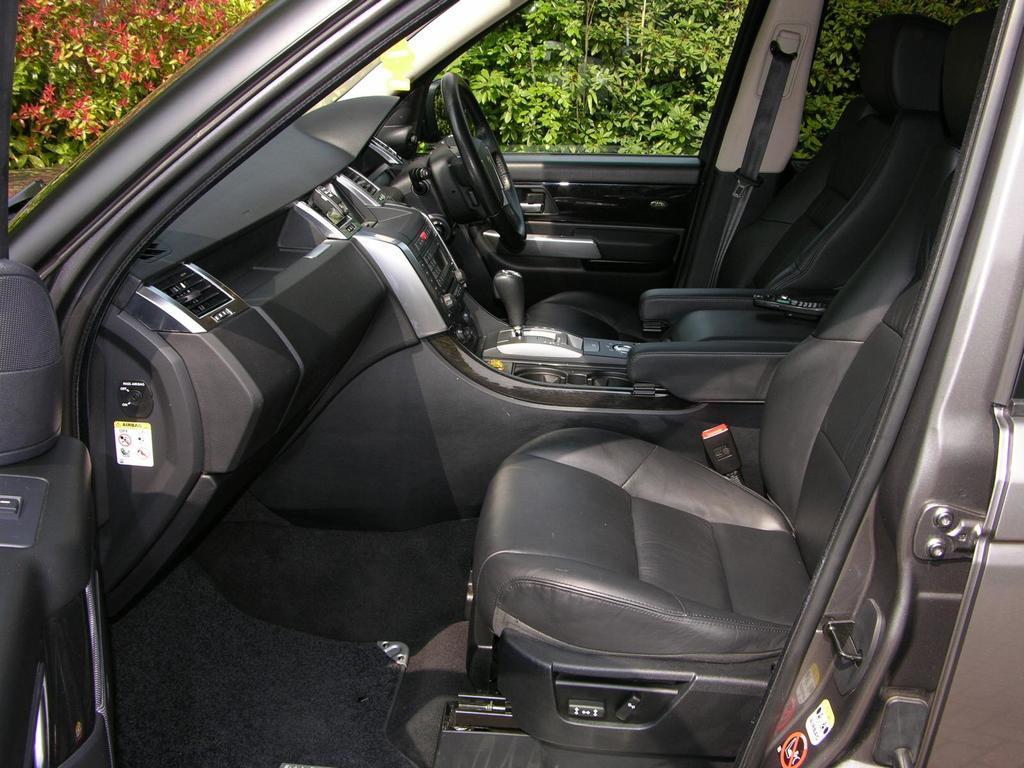Could you give a brief overview of what you see in this image? This is the inner view of a car. There are plants at the back. 